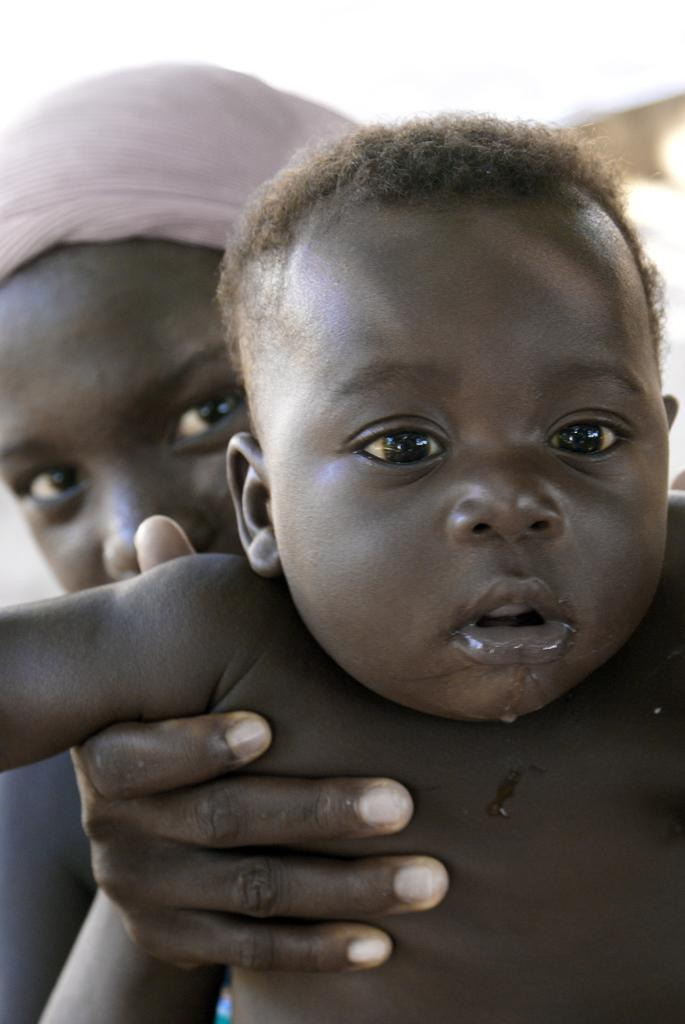Who is the main subject in the image? There is a woman in the image. What is the woman doing in the image? The woman is holding a baby. What color is the background of the image? The background of the image is white. How many keys are being distributed by the woman in the image? There are no keys present in the image; the woman is holding a baby. What type of houses can be seen in the background of the image? There are no houses visible in the image, as the background is white. 